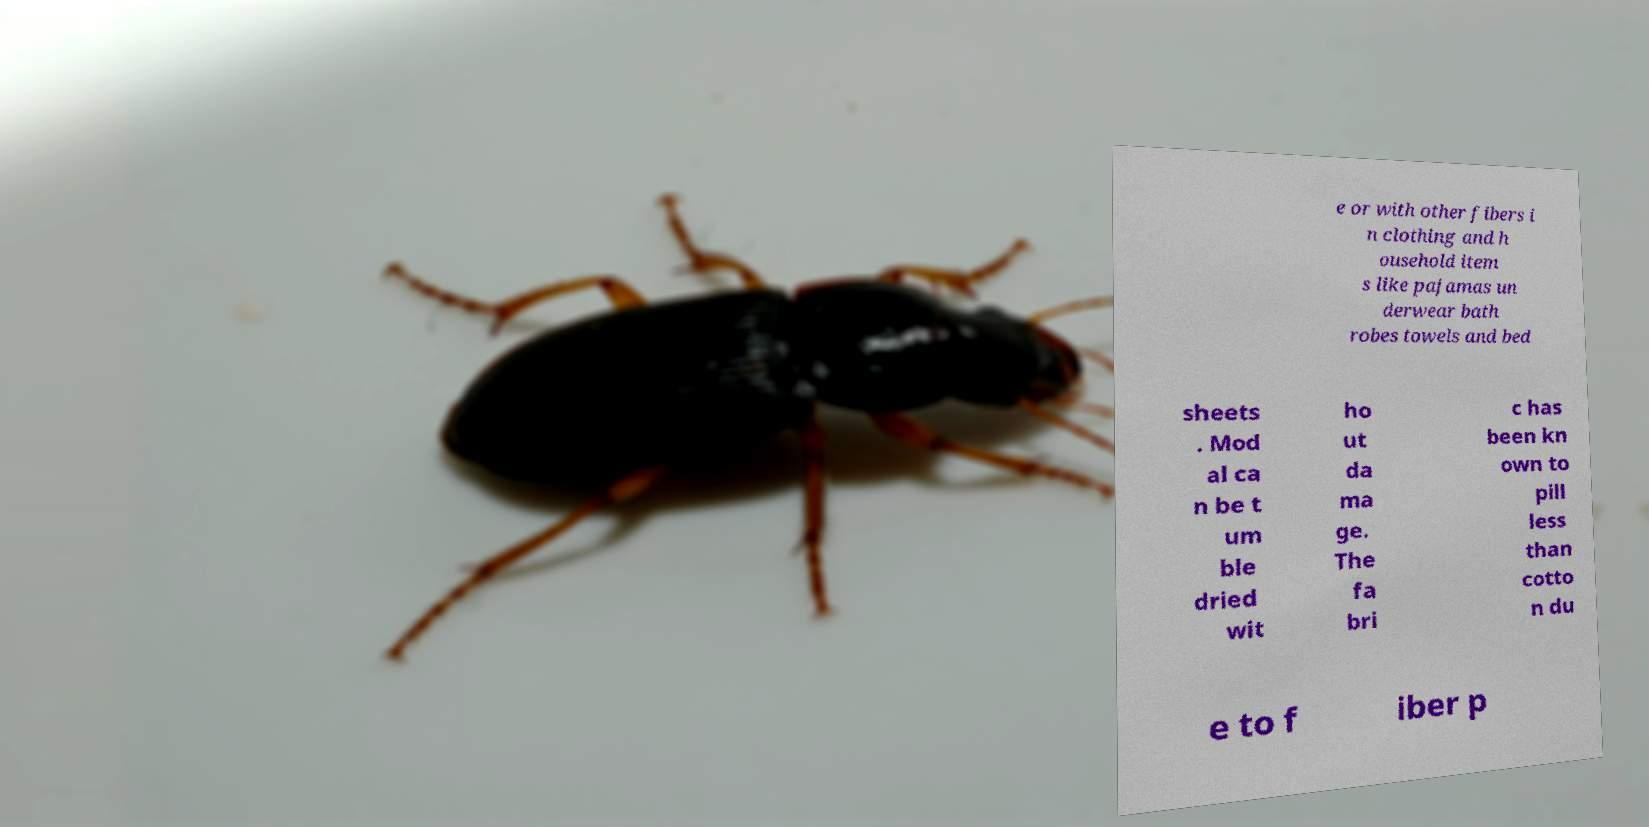Can you accurately transcribe the text from the provided image for me? e or with other fibers i n clothing and h ousehold item s like pajamas un derwear bath robes towels and bed sheets . Mod al ca n be t um ble dried wit ho ut da ma ge. The fa bri c has been kn own to pill less than cotto n du e to f iber p 